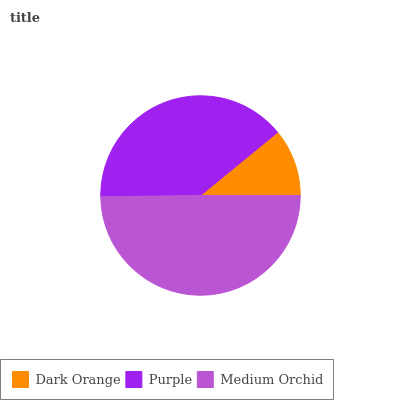Is Dark Orange the minimum?
Answer yes or no. Yes. Is Medium Orchid the maximum?
Answer yes or no. Yes. Is Purple the minimum?
Answer yes or no. No. Is Purple the maximum?
Answer yes or no. No. Is Purple greater than Dark Orange?
Answer yes or no. Yes. Is Dark Orange less than Purple?
Answer yes or no. Yes. Is Dark Orange greater than Purple?
Answer yes or no. No. Is Purple less than Dark Orange?
Answer yes or no. No. Is Purple the high median?
Answer yes or no. Yes. Is Purple the low median?
Answer yes or no. Yes. Is Medium Orchid the high median?
Answer yes or no. No. Is Dark Orange the low median?
Answer yes or no. No. 